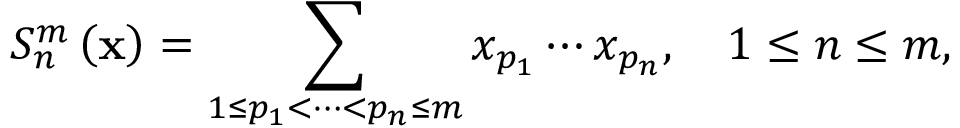Convert formula to latex. <formula><loc_0><loc_0><loc_500><loc_500>S _ { n } ^ { m } \left ( x \right ) = \sum _ { 1 \leq p _ { 1 } < \cdots < p _ { n } \leq m } x _ { p _ { 1 } } \cdots x _ { p _ { n } } , \quad 1 \leq n \leq m ,</formula> 